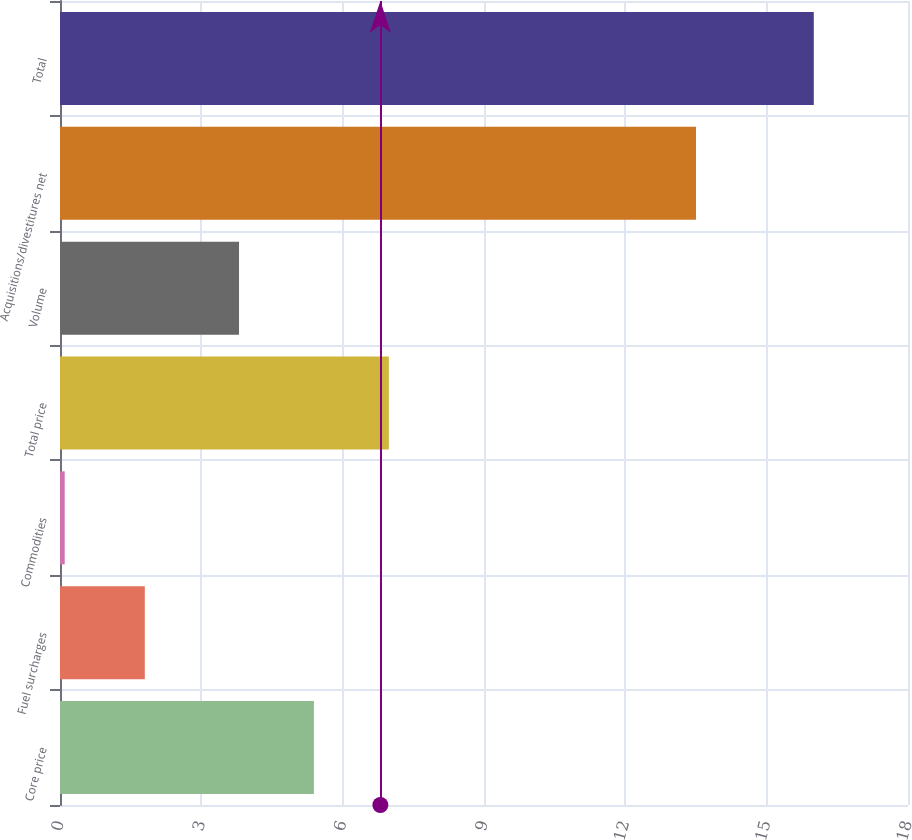Convert chart to OTSL. <chart><loc_0><loc_0><loc_500><loc_500><bar_chart><fcel>Core price<fcel>Fuel surcharges<fcel>Commodities<fcel>Total price<fcel>Volume<fcel>Acquisitions/divestitures net<fcel>Total<nl><fcel>5.39<fcel>1.8<fcel>0.1<fcel>6.98<fcel>3.8<fcel>13.5<fcel>16<nl></chart> 